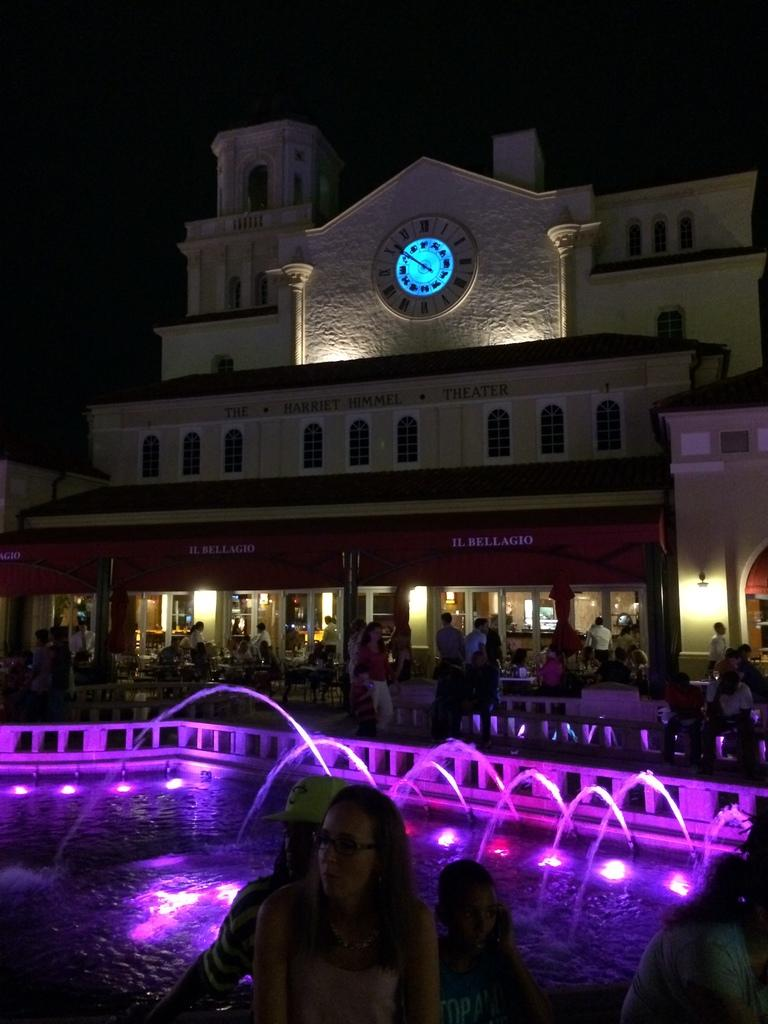What is the primary element visible in the image? There is water in the image. What other objects or structures can be seen in the image? There are lights, people, chairs, tables, poles, boards, a clock, and buildings in the image. Can you describe the lighting conditions in the image? The background of the image is dark. What type of detail can be seen on the team's uniforms in the image? There is no team or uniforms present in the image. What line is being formed by the people in the image? There is no line being formed by the people in the image; they are not arranged in a specific formation. 